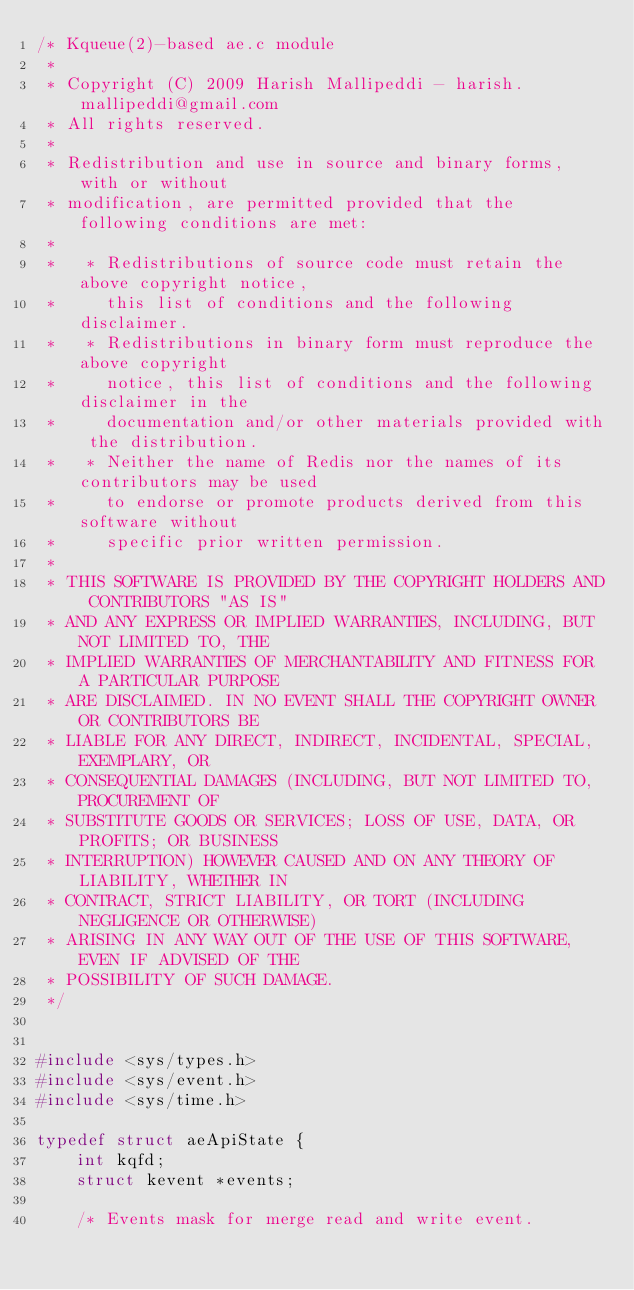Convert code to text. <code><loc_0><loc_0><loc_500><loc_500><_C_>/* Kqueue(2)-based ae.c module
 *
 * Copyright (C) 2009 Harish Mallipeddi - harish.mallipeddi@gmail.com
 * All rights reserved.
 *
 * Redistribution and use in source and binary forms, with or without
 * modification, are permitted provided that the following conditions are met:
 *
 *   * Redistributions of source code must retain the above copyright notice,
 *     this list of conditions and the following disclaimer.
 *   * Redistributions in binary form must reproduce the above copyright
 *     notice, this list of conditions and the following disclaimer in the
 *     documentation and/or other materials provided with the distribution.
 *   * Neither the name of Redis nor the names of its contributors may be used
 *     to endorse or promote products derived from this software without
 *     specific prior written permission.
 *
 * THIS SOFTWARE IS PROVIDED BY THE COPYRIGHT HOLDERS AND CONTRIBUTORS "AS IS"
 * AND ANY EXPRESS OR IMPLIED WARRANTIES, INCLUDING, BUT NOT LIMITED TO, THE
 * IMPLIED WARRANTIES OF MERCHANTABILITY AND FITNESS FOR A PARTICULAR PURPOSE
 * ARE DISCLAIMED. IN NO EVENT SHALL THE COPYRIGHT OWNER OR CONTRIBUTORS BE
 * LIABLE FOR ANY DIRECT, INDIRECT, INCIDENTAL, SPECIAL, EXEMPLARY, OR
 * CONSEQUENTIAL DAMAGES (INCLUDING, BUT NOT LIMITED TO, PROCUREMENT OF
 * SUBSTITUTE GOODS OR SERVICES; LOSS OF USE, DATA, OR PROFITS; OR BUSINESS
 * INTERRUPTION) HOWEVER CAUSED AND ON ANY THEORY OF LIABILITY, WHETHER IN
 * CONTRACT, STRICT LIABILITY, OR TORT (INCLUDING NEGLIGENCE OR OTHERWISE)
 * ARISING IN ANY WAY OUT OF THE USE OF THIS SOFTWARE, EVEN IF ADVISED OF THE
 * POSSIBILITY OF SUCH DAMAGE.
 */


#include <sys/types.h>
#include <sys/event.h>
#include <sys/time.h>

typedef struct aeApiState {
    int kqfd;
    struct kevent *events;

    /* Events mask for merge read and write event.</code> 